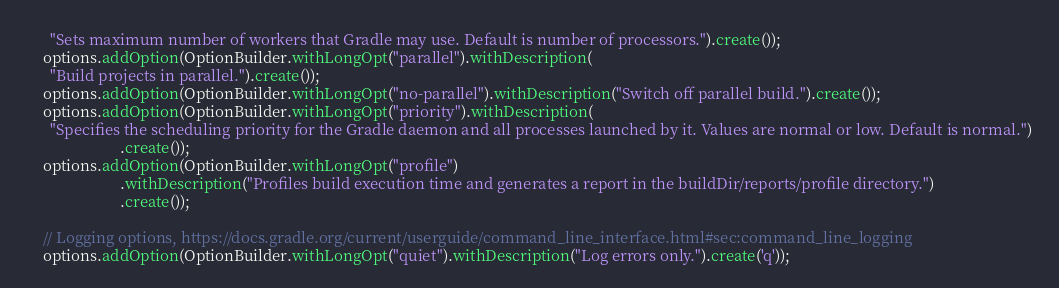<code> <loc_0><loc_0><loc_500><loc_500><_Java_>      "Sets maximum number of workers that Gradle may use. Default is number of processors.").create());
    options.addOption(OptionBuilder.withLongOpt("parallel").withDescription(
      "Build projects in parallel.").create());
    options.addOption(OptionBuilder.withLongOpt("no-parallel").withDescription("Switch off parallel build.").create());
    options.addOption(OptionBuilder.withLongOpt("priority").withDescription(
      "Specifies the scheduling priority for the Gradle daemon and all processes launched by it. Values are normal or low. Default is normal.")
                        .create());
    options.addOption(OptionBuilder.withLongOpt("profile")
                        .withDescription("Profiles build execution time and generates a report in the buildDir/reports/profile directory.")
                        .create());

    // Logging options, https://docs.gradle.org/current/userguide/command_line_interface.html#sec:command_line_logging
    options.addOption(OptionBuilder.withLongOpt("quiet").withDescription("Log errors only.").create('q'));</code> 